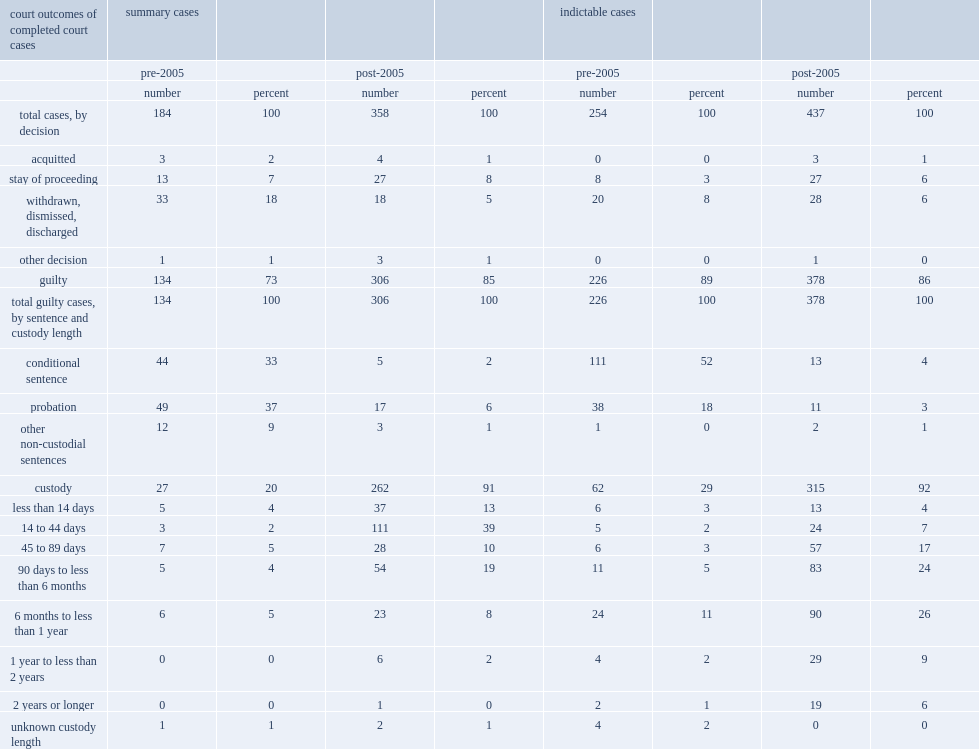What was the proportion of summary cases in conditional sentences before 2005? 33.0. What was the proportion of summary cases in probation before 2005? 37.0. What was the proporton of summary cases in other non-custodial sentences before 2005? 9.0. What was the total proportion of summary cases in conditional cases, probation and other non-custodial sentences before 2005? 79. What was the proportion of indictable cases in conditional sentences before 2005? 52.0. What was the proportion of indictable cases in probation before 2005? 18.0. What was the total proportion of indictable cases that resulted in conditional sentences, probation and other non-custodial sentences before 2005? 70. What was the proportion of indictable cases in other non-custodial sentences before 2005? 0.0. 